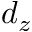<formula> <loc_0><loc_0><loc_500><loc_500>d _ { z }</formula> 